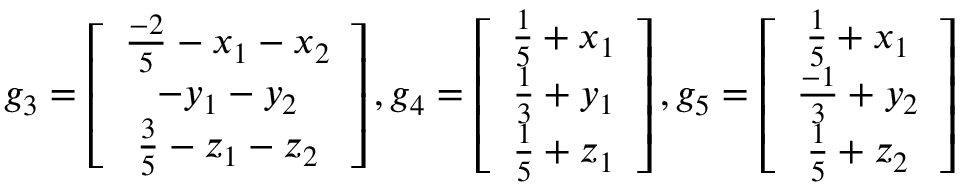Convert formula to latex. <formula><loc_0><loc_0><loc_500><loc_500>g _ { 3 } = \left [ \begin{array} { c c c } { \frac { - 2 } { 5 } - x _ { 1 } - x _ { 2 } } \\ { - y _ { 1 } - y _ { 2 } } \\ { \frac { 3 } { 5 } - z _ { 1 } - z _ { 2 } } \end{array} \right ] , g _ { 4 } = \left [ \begin{array} { c c c } { \frac { 1 } { 5 } + x _ { 1 } } \\ { \frac { 1 } { 3 } + y _ { 1 } } \\ { \frac { 1 } { 5 } + z _ { 1 } } \end{array} \right ] , g _ { 5 } = \left [ \begin{array} { c c c } { \frac { 1 } { 5 } + x _ { 1 } } \\ { \frac { - 1 } { 3 } + y _ { 2 } } \\ { \frac { 1 } { 5 } + z _ { 2 } } \end{array} \right ]</formula> 